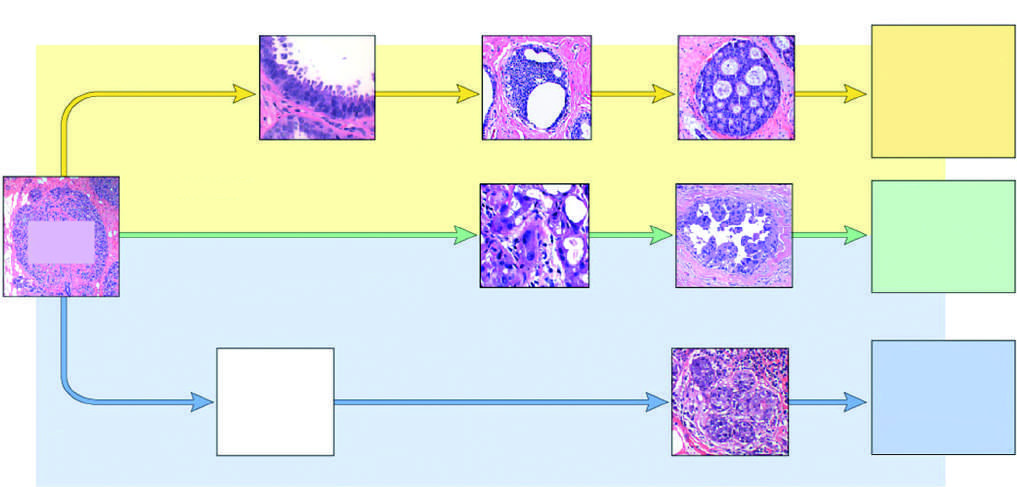s this the type of cancer that arises most commonly in individuals with germline brca2 mutations?
Answer the question using a single word or phrase. Yes 